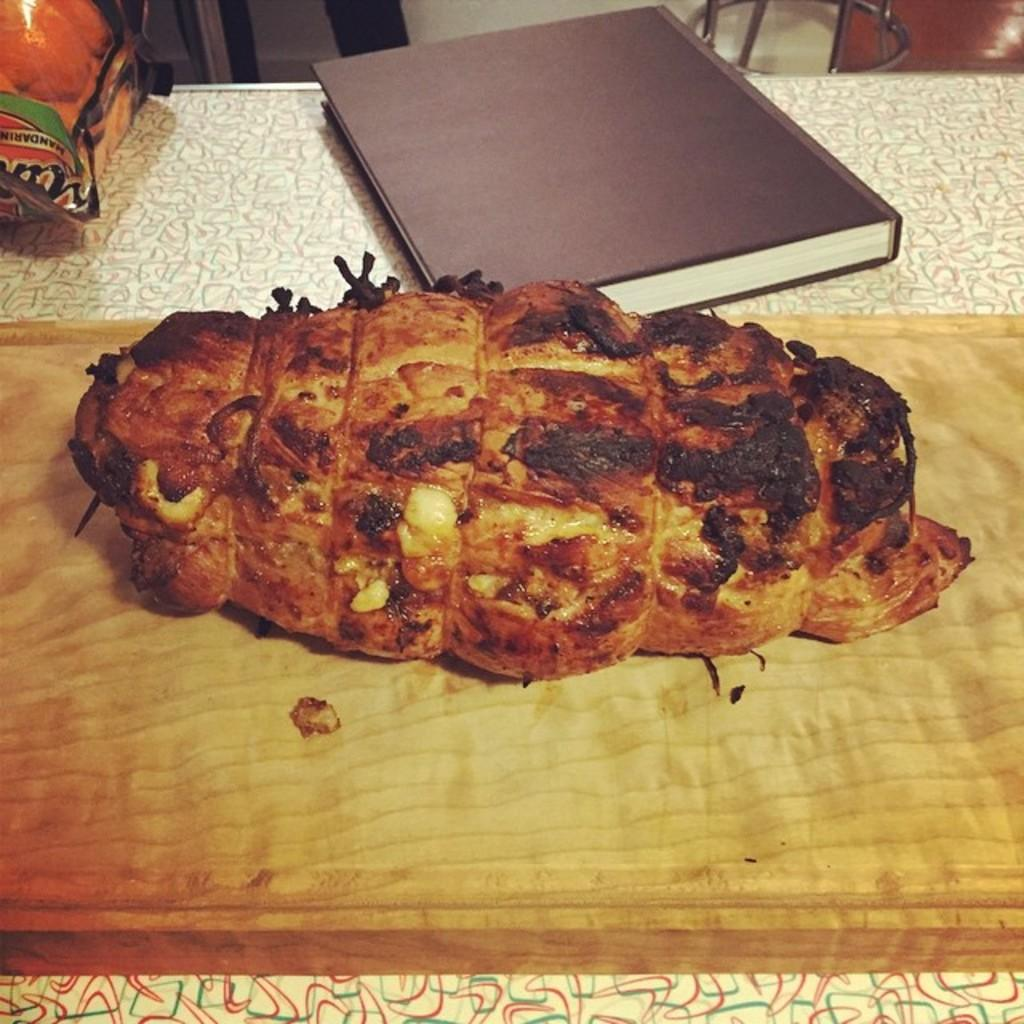What is the main object on the wooden platter in the image? There is food on the wooden platter in the image. What other objects are near the wooden platter? There is a book and an unspecified "thing" beside the wooden platter. Can you describe the setting of the image? The top of the image contains rods, a wall, and a floor. How many goldfish are swimming in the wooden platter in the image? There are no goldfish present in the image; it features a wooden platter with food on it. What type of thread is being used to sew the man's shirt in the image? There is no man or shirt present in the image; it only contains a wooden platter, food, a book, an unspecified "thing," rods, a wall, and a floor. 